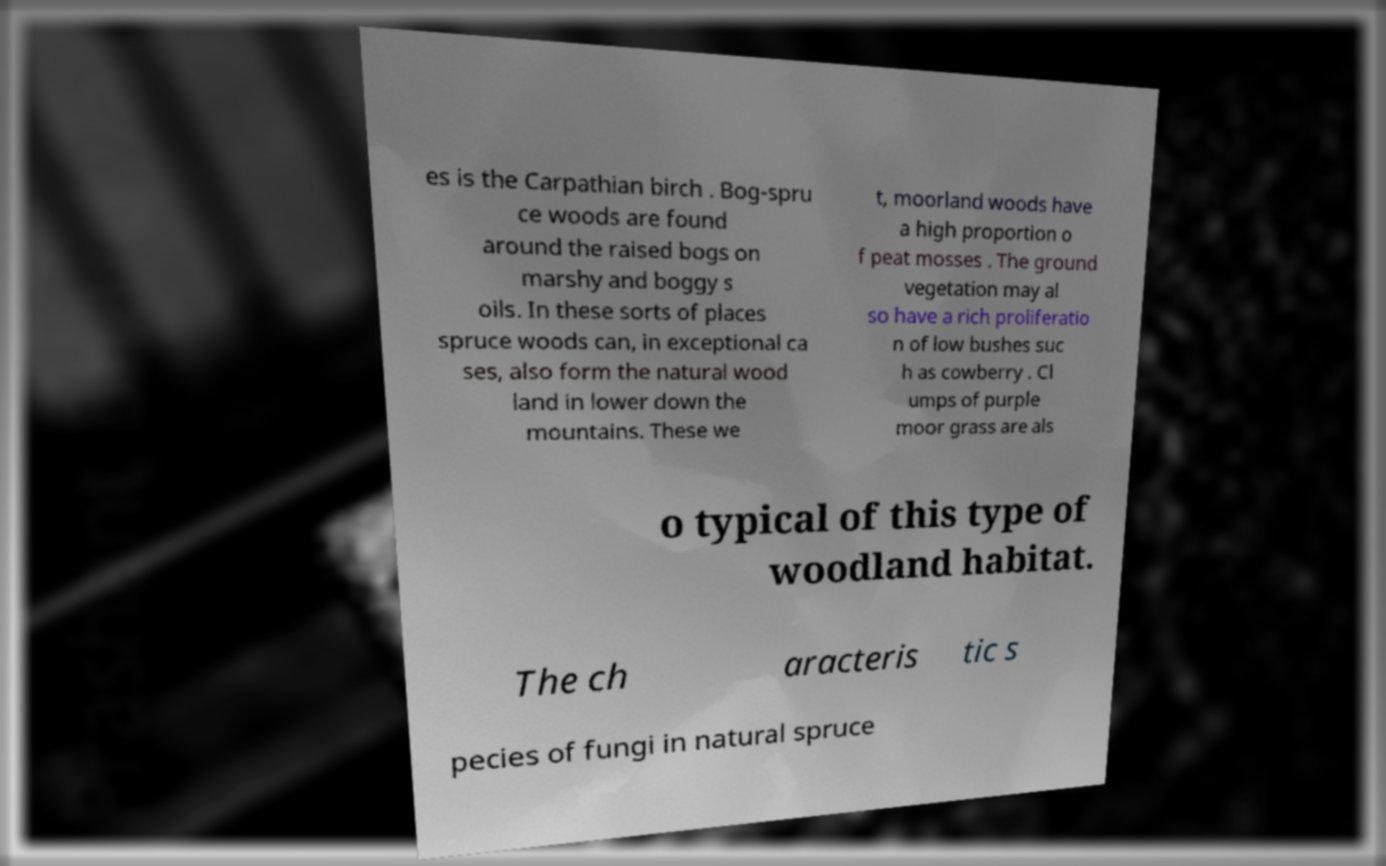For documentation purposes, I need the text within this image transcribed. Could you provide that? es is the Carpathian birch . Bog-spru ce woods are found around the raised bogs on marshy and boggy s oils. In these sorts of places spruce woods can, in exceptional ca ses, also form the natural wood land in lower down the mountains. These we t, moorland woods have a high proportion o f peat mosses . The ground vegetation may al so have a rich proliferatio n of low bushes suc h as cowberry . Cl umps of purple moor grass are als o typical of this type of woodland habitat. The ch aracteris tic s pecies of fungi in natural spruce 